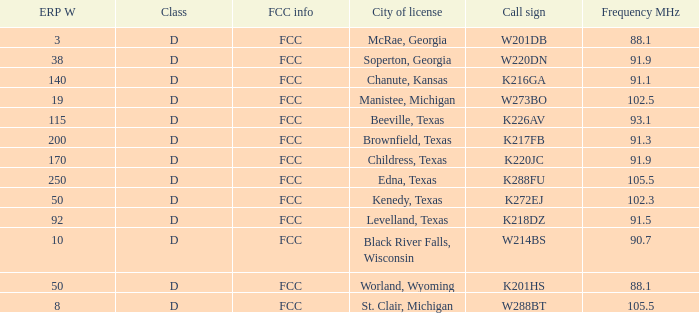What is Call Sign, when ERP W is greater than 50? K216GA, K226AV, K217FB, K220JC, K288FU, K218DZ. 